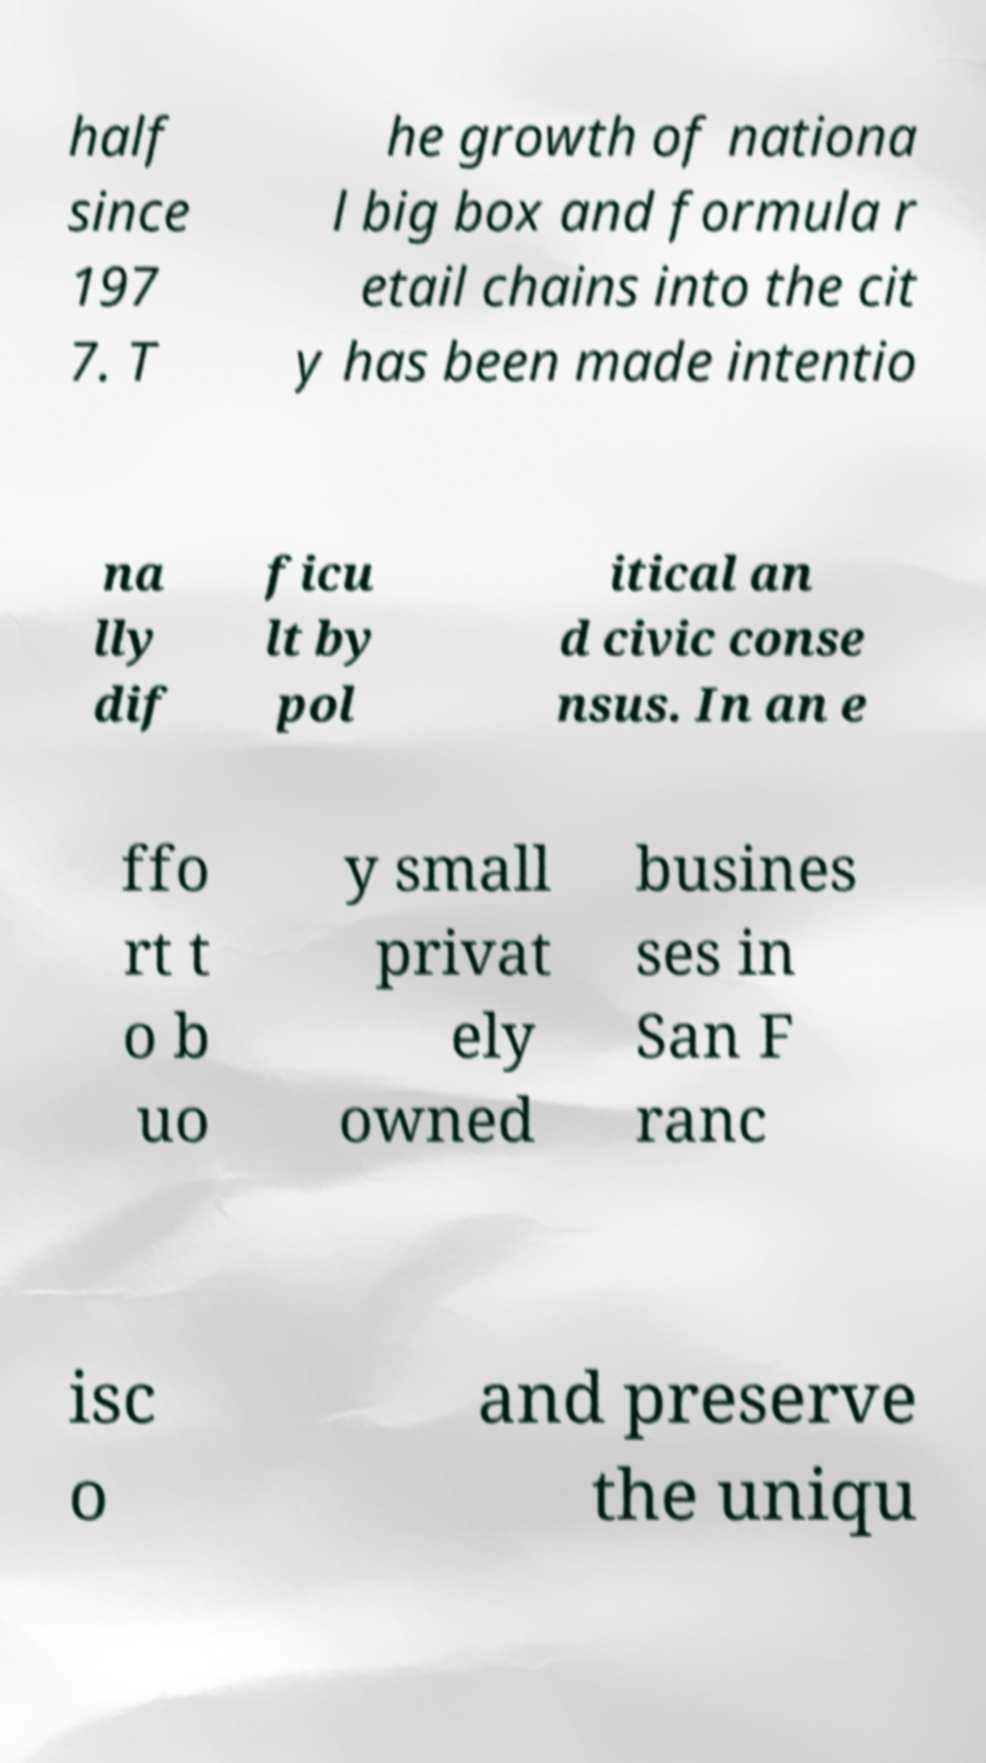Please read and relay the text visible in this image. What does it say? half since 197 7. T he growth of nationa l big box and formula r etail chains into the cit y has been made intentio na lly dif ficu lt by pol itical an d civic conse nsus. In an e ffo rt t o b uo y small privat ely owned busines ses in San F ranc isc o and preserve the uniqu 